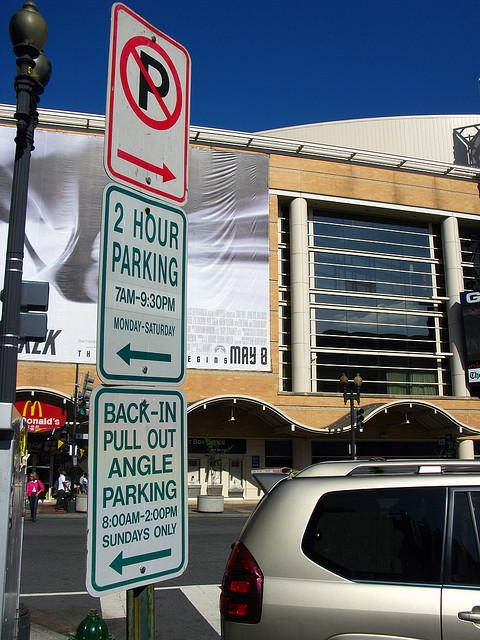The billboard on the building is advertising for which science fiction franchise? Please explain your reasoning. star trek. The sign on the building is advertising for a star trek movie. 